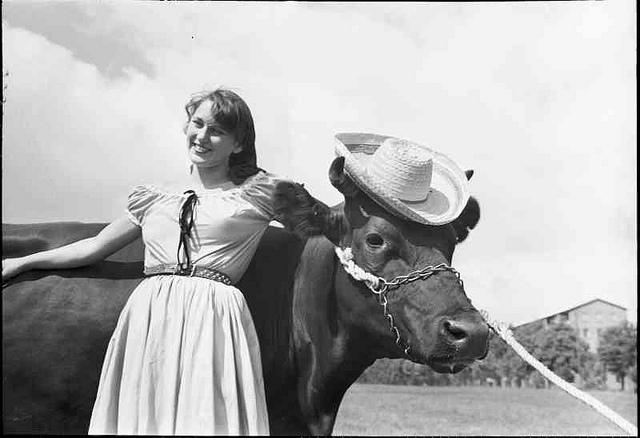Could the cow be named Betsy?
Keep it brief. Yes. What year was this taken?
Quick response, please. 1960. Who is wearing the hat?
Keep it brief. Cow. 